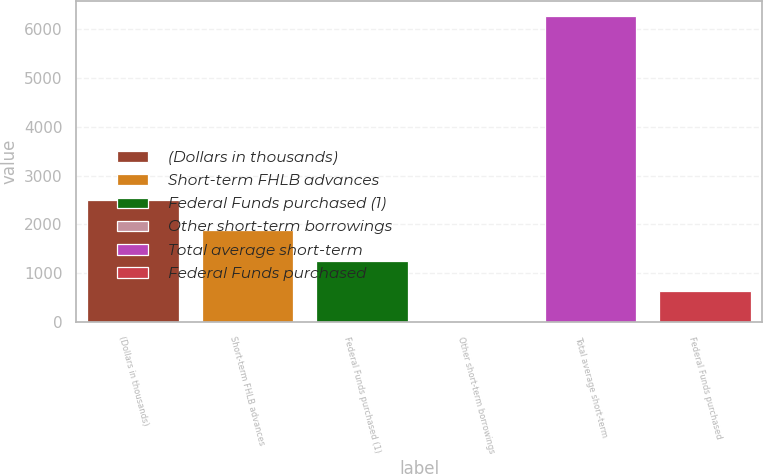Convert chart. <chart><loc_0><loc_0><loc_500><loc_500><bar_chart><fcel>(Dollars in thousands)<fcel>Short-term FHLB advances<fcel>Federal Funds purchased (1)<fcel>Other short-term borrowings<fcel>Total average short-term<fcel>Federal Funds purchased<nl><fcel>2505.64<fcel>1879.24<fcel>1252.84<fcel>0.04<fcel>6264<fcel>626.44<nl></chart> 